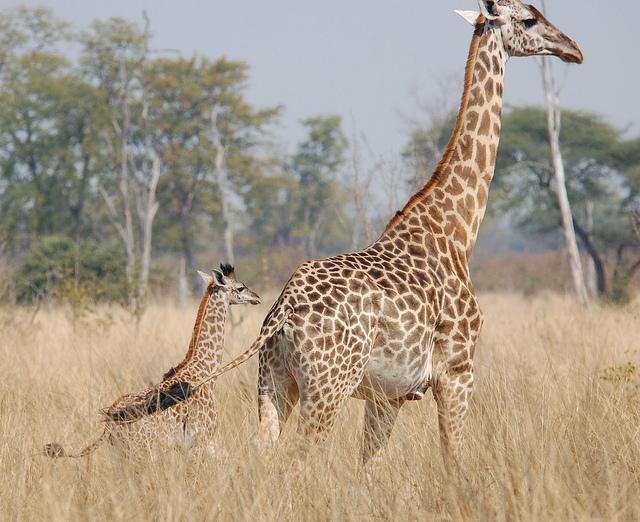How many giraffe are in the field?
Short answer required. 2. Where are they located?
Give a very brief answer. Savannah. Is there a baby giraffe?
Short answer required. Yes. How many giraffes are there?
Give a very brief answer. 2. How many giraffe are walking across the field?
Quick response, please. 2. 